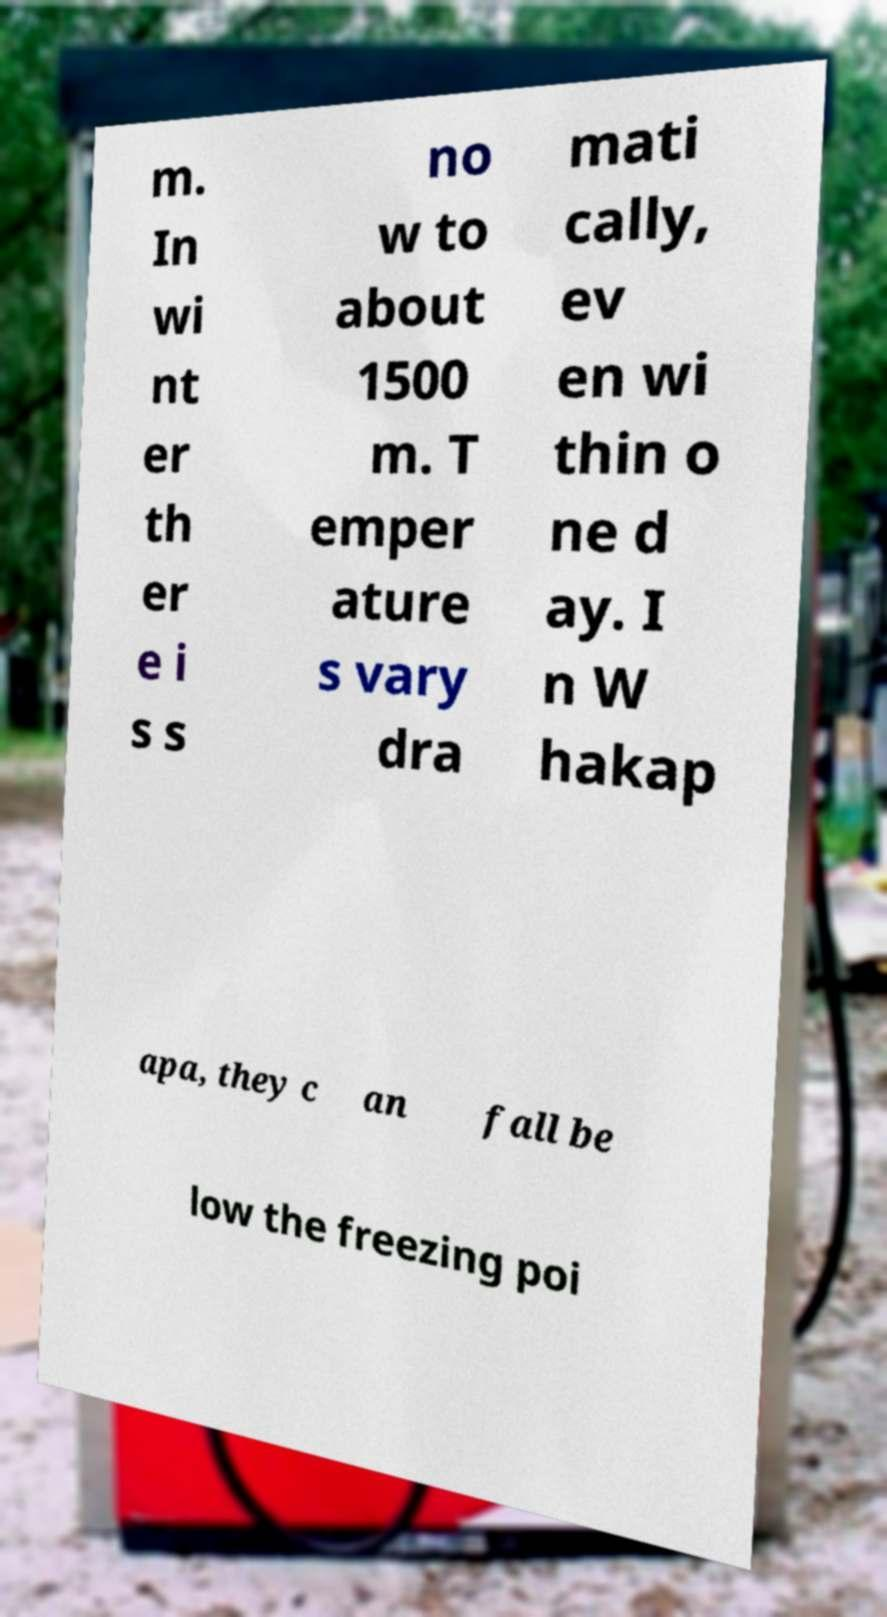Could you extract and type out the text from this image? m. In wi nt er th er e i s s no w to about 1500 m. T emper ature s vary dra mati cally, ev en wi thin o ne d ay. I n W hakap apa, they c an fall be low the freezing poi 